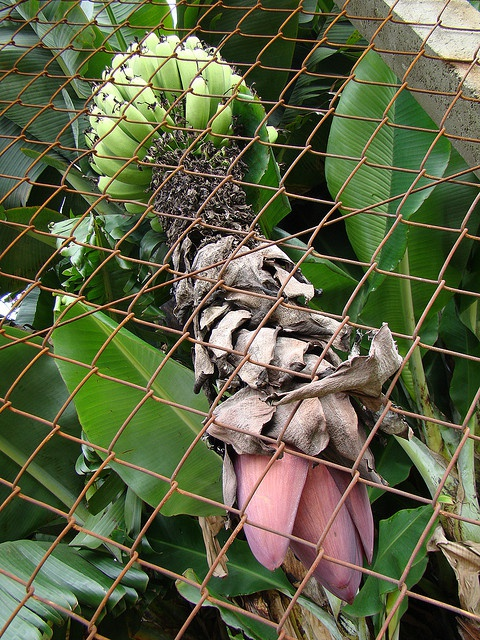Describe the objects in this image and their specific colors. I can see a banana in gray, khaki, olive, lightyellow, and darkgreen tones in this image. 